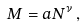<formula> <loc_0><loc_0><loc_500><loc_500>M = a N ^ { \nu } \, ,</formula> 